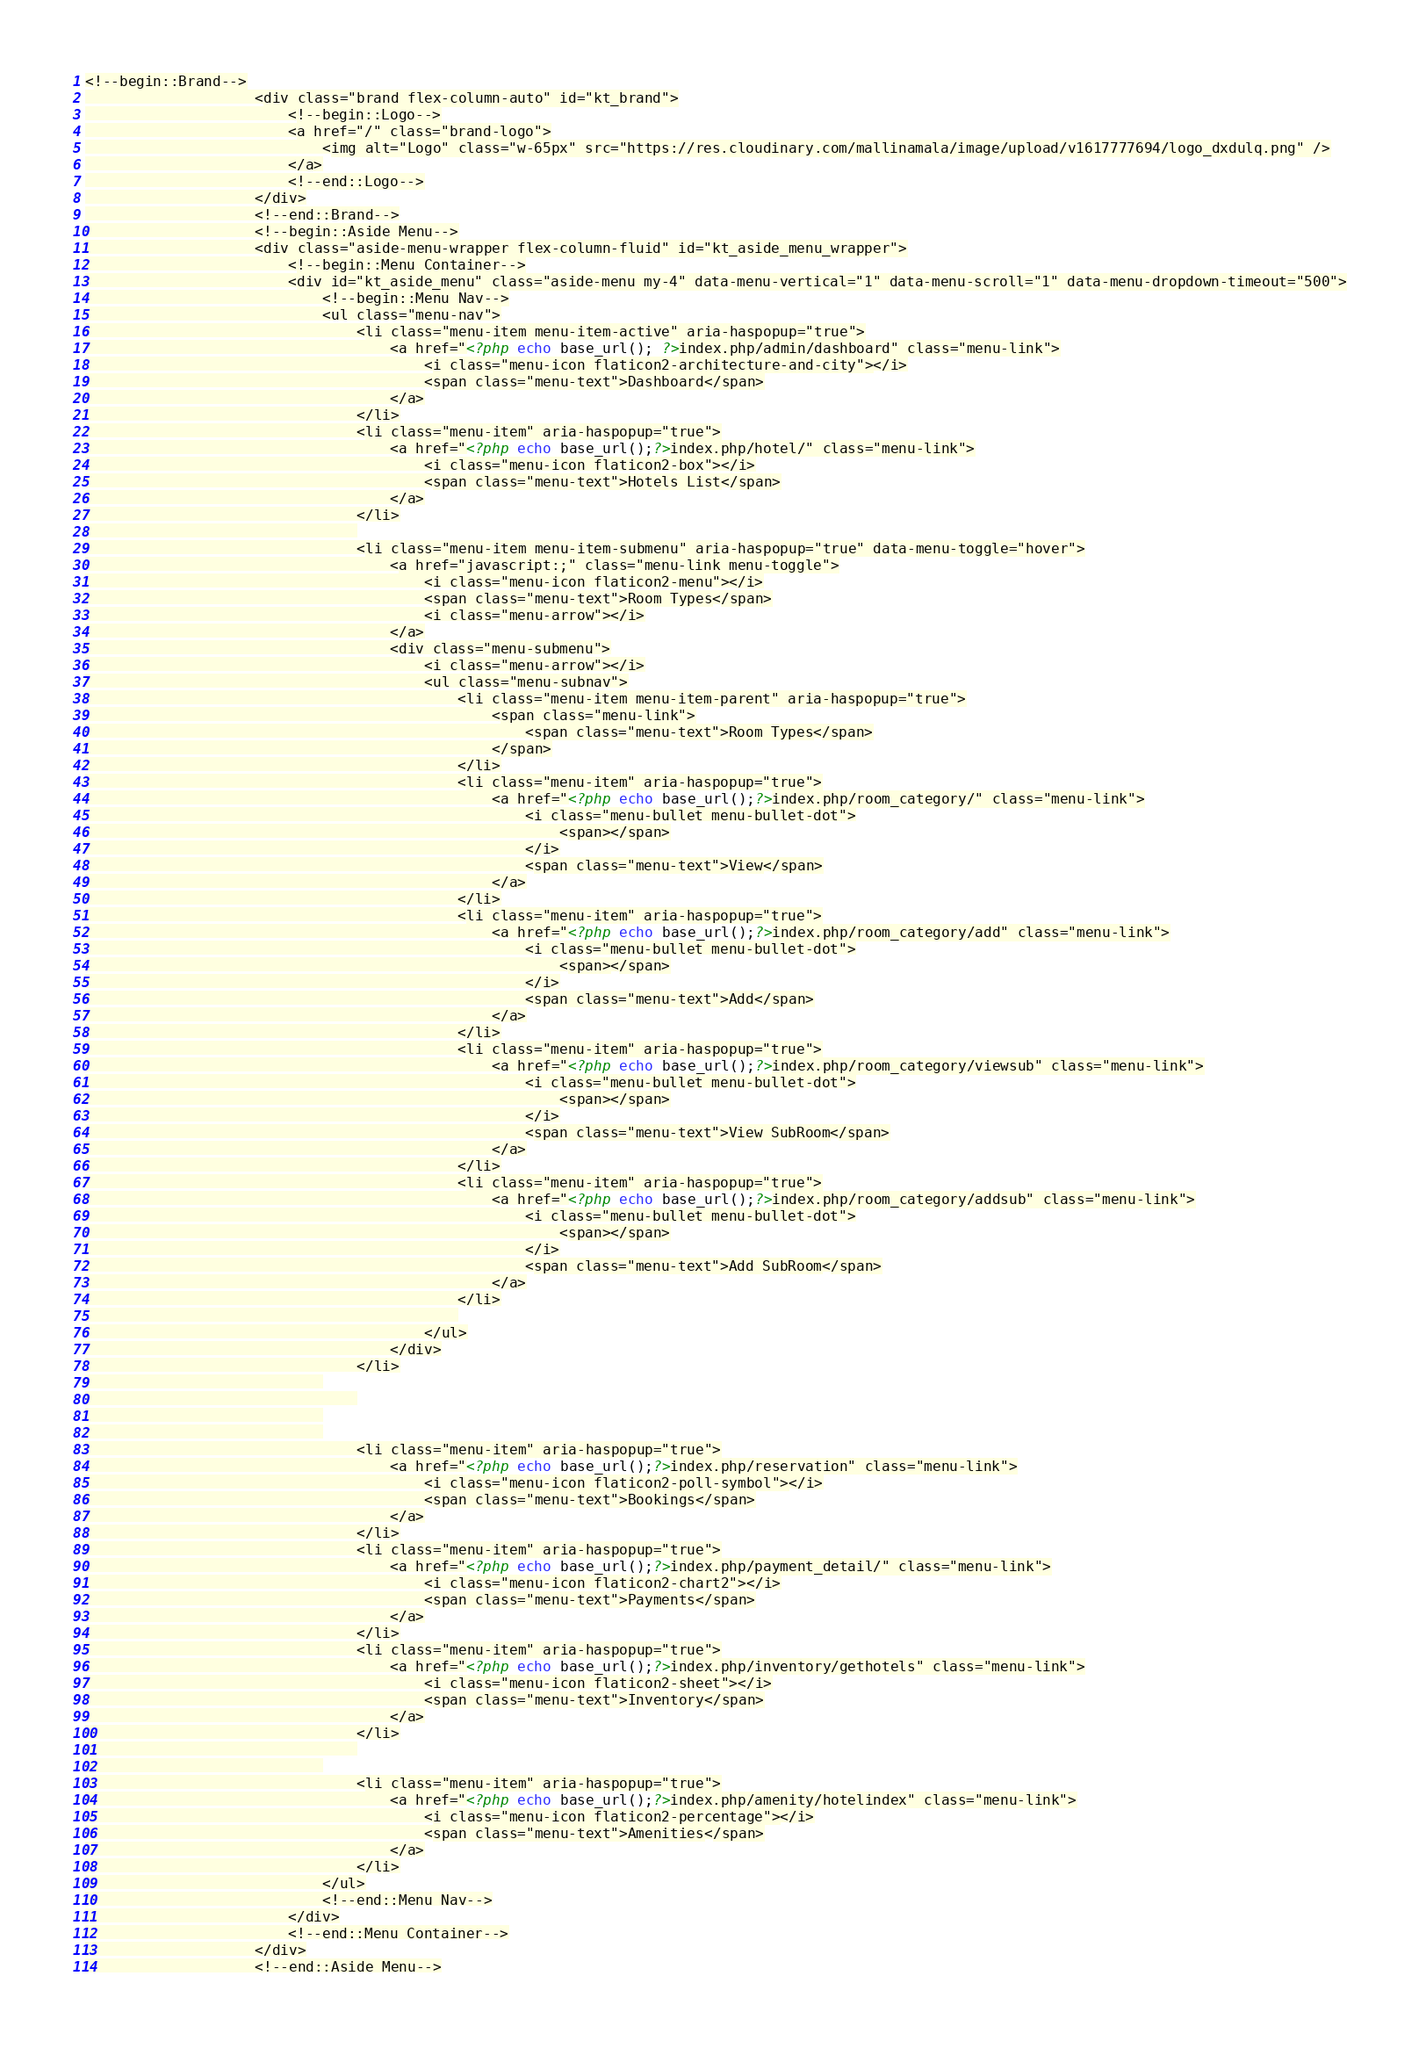Convert code to text. <code><loc_0><loc_0><loc_500><loc_500><_PHP_><!--begin::Brand-->
					<div class="brand flex-column-auto" id="kt_brand">
						<!--begin::Logo-->
						<a href="/" class="brand-logo">
							<img alt="Logo" class="w-65px" src="https://res.cloudinary.com/mallinamala/image/upload/v1617777694/logo_dxdulq.png" />
						</a>
						<!--end::Logo-->
					</div>
					<!--end::Brand-->
					<!--begin::Aside Menu-->
					<div class="aside-menu-wrapper flex-column-fluid" id="kt_aside_menu_wrapper">
						<!--begin::Menu Container-->
						<div id="kt_aside_menu" class="aside-menu my-4" data-menu-vertical="1" data-menu-scroll="1" data-menu-dropdown-timeout="500">
							<!--begin::Menu Nav-->
							<ul class="menu-nav">
								<li class="menu-item menu-item-active" aria-haspopup="true">
									<a href="<?php echo base_url(); ?>index.php/admin/dashboard" class="menu-link">
										<i class="menu-icon flaticon2-architecture-and-city"></i>
										<span class="menu-text">Dashboard</span>
									</a>
								</li>
								<li class="menu-item" aria-haspopup="true">
									<a href="<?php echo base_url();?>index.php/hotel/" class="menu-link">
										<i class="menu-icon flaticon2-box"></i>
										<span class="menu-text">Hotels List</span>
									</a>
								</li>
								
								<li class="menu-item menu-item-submenu" aria-haspopup="true" data-menu-toggle="hover">
									<a href="javascript:;" class="menu-link menu-toggle">
										<i class="menu-icon flaticon2-menu"></i>
										<span class="menu-text">Room Types</span>
										<i class="menu-arrow"></i>
									</a>
									<div class="menu-submenu">
										<i class="menu-arrow"></i>
										<ul class="menu-subnav">
											<li class="menu-item menu-item-parent" aria-haspopup="true">
												<span class="menu-link">
													<span class="menu-text">Room Types</span>
												</span>
											</li>
											<li class="menu-item" aria-haspopup="true">
												<a href="<?php echo base_url();?>index.php/room_category/" class="menu-link">
													<i class="menu-bullet menu-bullet-dot">
														<span></span>
													</i>
													<span class="menu-text">View</span>
												</a>
											</li>
											<li class="menu-item" aria-haspopup="true">
												<a href="<?php echo base_url();?>index.php/room_category/add" class="menu-link">
													<i class="menu-bullet menu-bullet-dot">
														<span></span>
													</i>
													<span class="menu-text">Add</span>
												</a>
											</li>
											<li class="menu-item" aria-haspopup="true">
												<a href="<?php echo base_url();?>index.php/room_category/viewsub" class="menu-link">
													<i class="menu-bullet menu-bullet-dot">
														<span></span>
													</i>
													<span class="menu-text">View SubRoom</span>
												</a>
											</li>
											<li class="menu-item" aria-haspopup="true">
												<a href="<?php echo base_url();?>index.php/room_category/addsub" class="menu-link">
													<i class="menu-bullet menu-bullet-dot">
														<span></span>
													</i>
													<span class="menu-text">Add SubRoom</span>
												</a>
											</li>
											
										</ul>
									</div>
								</li>
							
								
							
							
								<li class="menu-item" aria-haspopup="true">
									<a href="<?php echo base_url();?>index.php/reservation" class="menu-link">
										<i class="menu-icon flaticon2-poll-symbol"></i>
										<span class="menu-text">Bookings</span>
									</a>
								</li>
								<li class="menu-item" aria-haspopup="true">
									<a href="<?php echo base_url();?>index.php/payment_detail/" class="menu-link">
										<i class="menu-icon flaticon2-chart2"></i>
										<span class="menu-text">Payments</span>
									</a>
								</li>
								<li class="menu-item" aria-haspopup="true">
									<a href="<?php echo base_url();?>index.php/inventory/gethotels" class="menu-link">
										<i class="menu-icon flaticon2-sheet"></i>
										<span class="menu-text">Inventory</span>
									</a>
								</li>
								
							
								<li class="menu-item" aria-haspopup="true">
									<a href="<?php echo base_url();?>index.php/amenity/hotelindex" class="menu-link">
										<i class="menu-icon flaticon2-percentage"></i>
										<span class="menu-text">Amenities</span>
									</a>
								</li>
							</ul>
							<!--end::Menu Nav-->
						</div>
						<!--end::Menu Container-->
					</div>
					<!--end::Aside Menu--></code> 